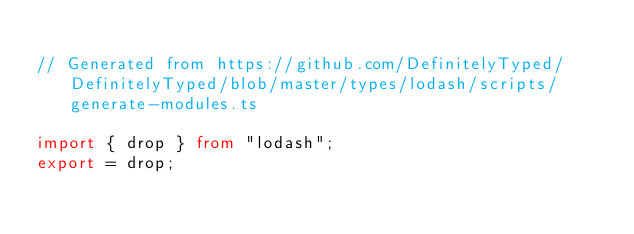<code> <loc_0><loc_0><loc_500><loc_500><_TypeScript_>
// Generated from https://github.com/DefinitelyTyped/DefinitelyTyped/blob/master/types/lodash/scripts/generate-modules.ts

import { drop } from "lodash";
export = drop;
</code> 